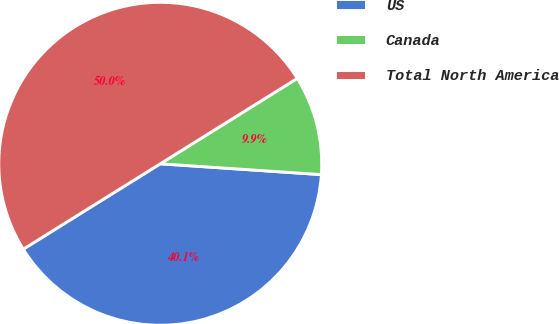Convert chart. <chart><loc_0><loc_0><loc_500><loc_500><pie_chart><fcel>US<fcel>Canada<fcel>Total North America<nl><fcel>40.06%<fcel>9.94%<fcel>50.0%<nl></chart> 